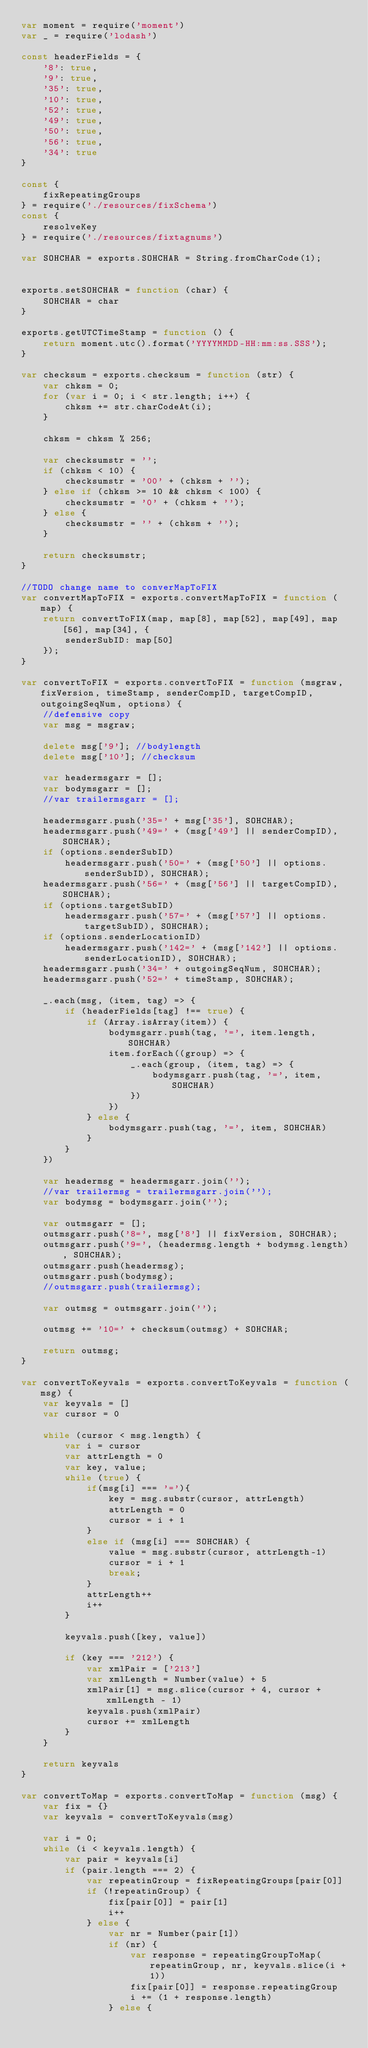<code> <loc_0><loc_0><loc_500><loc_500><_JavaScript_>var moment = require('moment')
var _ = require('lodash')

const headerFields = {
    '8': true,
    '9': true,
    '35': true,
    '10': true,
    '52': true,
    '49': true,
    '50': true,
    '56': true,
    '34': true
}

const {
    fixRepeatingGroups
} = require('./resources/fixSchema')
const {
    resolveKey
} = require('./resources/fixtagnums')

var SOHCHAR = exports.SOHCHAR = String.fromCharCode(1);


exports.setSOHCHAR = function (char) {
    SOHCHAR = char
}

exports.getUTCTimeStamp = function () {
    return moment.utc().format('YYYYMMDD-HH:mm:ss.SSS');
}

var checksum = exports.checksum = function (str) {
    var chksm = 0;
    for (var i = 0; i < str.length; i++) {
        chksm += str.charCodeAt(i);
    }

    chksm = chksm % 256;

    var checksumstr = '';
    if (chksm < 10) {
        checksumstr = '00' + (chksm + '');
    } else if (chksm >= 10 && chksm < 100) {
        checksumstr = '0' + (chksm + '');
    } else {
        checksumstr = '' + (chksm + '');
    }

    return checksumstr;
}

//TODO change name to converMapToFIX
var convertMapToFIX = exports.convertMapToFIX = function (map) {
    return convertToFIX(map, map[8], map[52], map[49], map[56], map[34], {
        senderSubID: map[50]
    });
}

var convertToFIX = exports.convertToFIX = function (msgraw, fixVersion, timeStamp, senderCompID, targetCompID, outgoingSeqNum, options) {
    //defensive copy
    var msg = msgraw;

    delete msg['9']; //bodylength
    delete msg['10']; //checksum

    var headermsgarr = [];
    var bodymsgarr = [];
    //var trailermsgarr = [];

    headermsgarr.push('35=' + msg['35'], SOHCHAR);
    headermsgarr.push('49=' + (msg['49'] || senderCompID), SOHCHAR);
    if (options.senderSubID)
        headermsgarr.push('50=' + (msg['50'] || options.senderSubID), SOHCHAR);
    headermsgarr.push('56=' + (msg['56'] || targetCompID), SOHCHAR);
    if (options.targetSubID)
        headermsgarr.push('57=' + (msg['57'] || options.targetSubID), SOHCHAR);
    if (options.senderLocationID)
        headermsgarr.push('142=' + (msg['142'] || options.senderLocationID), SOHCHAR);
    headermsgarr.push('34=' + outgoingSeqNum, SOHCHAR);
    headermsgarr.push('52=' + timeStamp, SOHCHAR);

    _.each(msg, (item, tag) => {
        if (headerFields[tag] !== true) {
            if (Array.isArray(item)) {
                bodymsgarr.push(tag, '=', item.length, SOHCHAR)
                item.forEach((group) => {
                    _.each(group, (item, tag) => {
                        bodymsgarr.push(tag, '=', item, SOHCHAR)
                    })
                })
            } else {
                bodymsgarr.push(tag, '=', item, SOHCHAR)
            }
        }
    })

    var headermsg = headermsgarr.join('');
    //var trailermsg = trailermsgarr.join('');
    var bodymsg = bodymsgarr.join('');

    var outmsgarr = [];
    outmsgarr.push('8=', msg['8'] || fixVersion, SOHCHAR);
    outmsgarr.push('9=', (headermsg.length + bodymsg.length), SOHCHAR);
    outmsgarr.push(headermsg);
    outmsgarr.push(bodymsg);
    //outmsgarr.push(trailermsg);

    var outmsg = outmsgarr.join('');

    outmsg += '10=' + checksum(outmsg) + SOHCHAR;

    return outmsg;
}

var convertToKeyvals = exports.convertToKeyvals = function (msg) {
    var keyvals = []
    var cursor = 0

    while (cursor < msg.length) {
        var i = cursor
        var attrLength = 0
        var key, value;
        while (true) {
            if(msg[i] === '='){
                key = msg.substr(cursor, attrLength)
                attrLength = 0
                cursor = i + 1
            }
            else if (msg[i] === SOHCHAR) {
                value = msg.substr(cursor, attrLength-1)
                cursor = i + 1
                break;
            }
            attrLength++
            i++
        }

        keyvals.push([key, value])

        if (key === '212') {
            var xmlPair = ['213']
            var xmlLength = Number(value) + 5
            xmlPair[1] = msg.slice(cursor + 4, cursor + xmlLength - 1)
            keyvals.push(xmlPair)
            cursor += xmlLength
        }
    }

    return keyvals
}

var convertToMap = exports.convertToMap = function (msg) {
    var fix = {}
    var keyvals = convertToKeyvals(msg)

    var i = 0;
    while (i < keyvals.length) {
        var pair = keyvals[i]
        if (pair.length === 2) {
            var repeatinGroup = fixRepeatingGroups[pair[0]]
            if (!repeatinGroup) {
                fix[pair[0]] = pair[1]
                i++
            } else {
                var nr = Number(pair[1])
                if (nr) {
                    var response = repeatingGroupToMap(repeatinGroup, nr, keyvals.slice(i + 1))
                    fix[pair[0]] = response.repeatingGroup
                    i += (1 + response.length)
                } else {</code> 